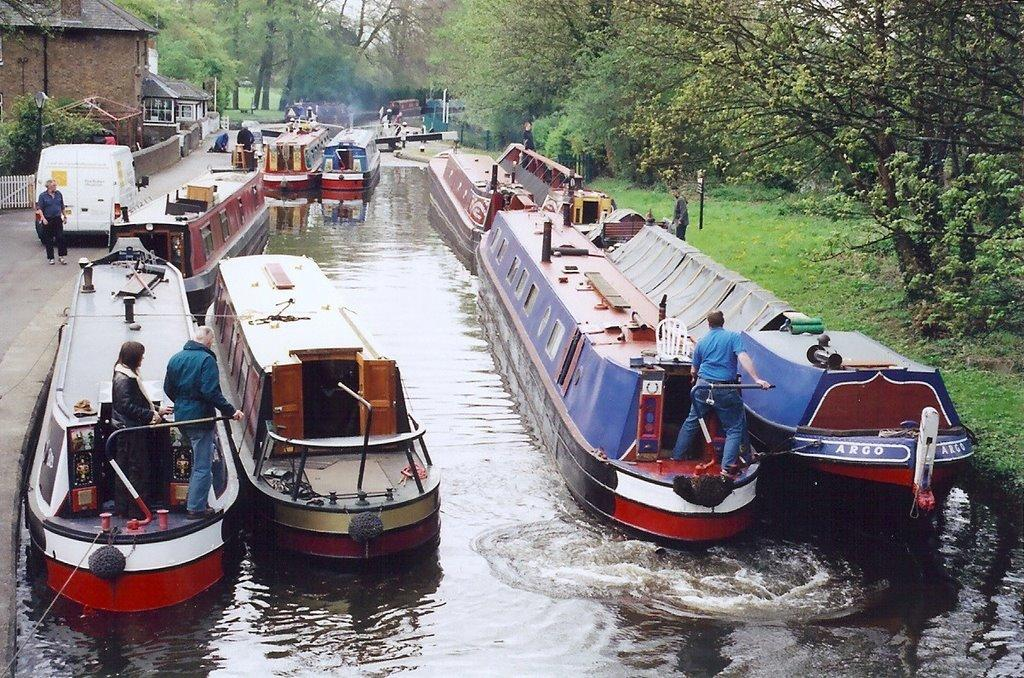Provide a one-sentence caption for the provided image. A few red, blue and white large boats with one being called Argo. 